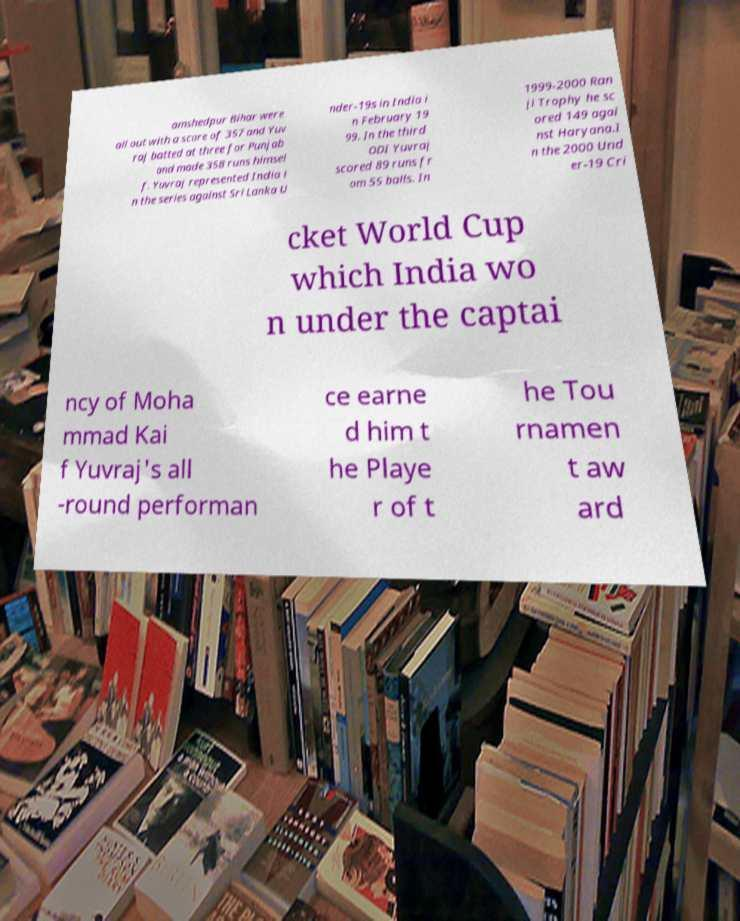Please identify and transcribe the text found in this image. amshedpur Bihar were all out with a score of 357 and Yuv raj batted at three for Punjab and made 358 runs himsel f. Yuvraj represented India i n the series against Sri Lanka U nder-19s in India i n February 19 99. In the third ODI Yuvraj scored 89 runs fr om 55 balls. In 1999-2000 Ran ji Trophy he sc ored 149 agai nst Haryana.I n the 2000 Und er-19 Cri cket World Cup which India wo n under the captai ncy of Moha mmad Kai f Yuvraj's all -round performan ce earne d him t he Playe r of t he Tou rnamen t aw ard 